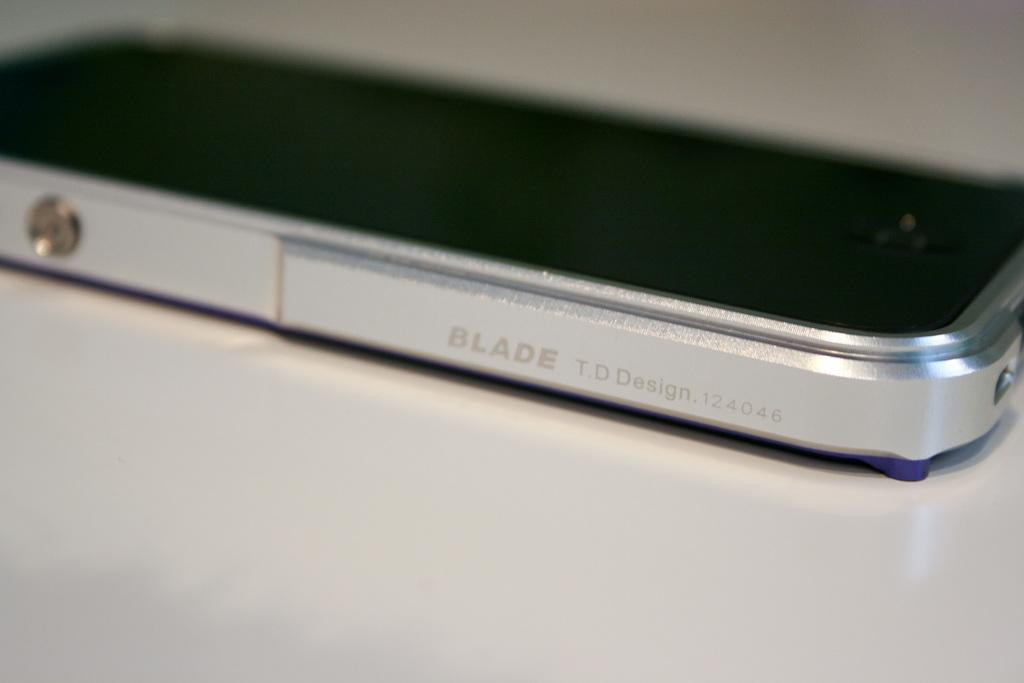<image>
Relay a brief, clear account of the picture shown. the word blade is on the side of a phone 